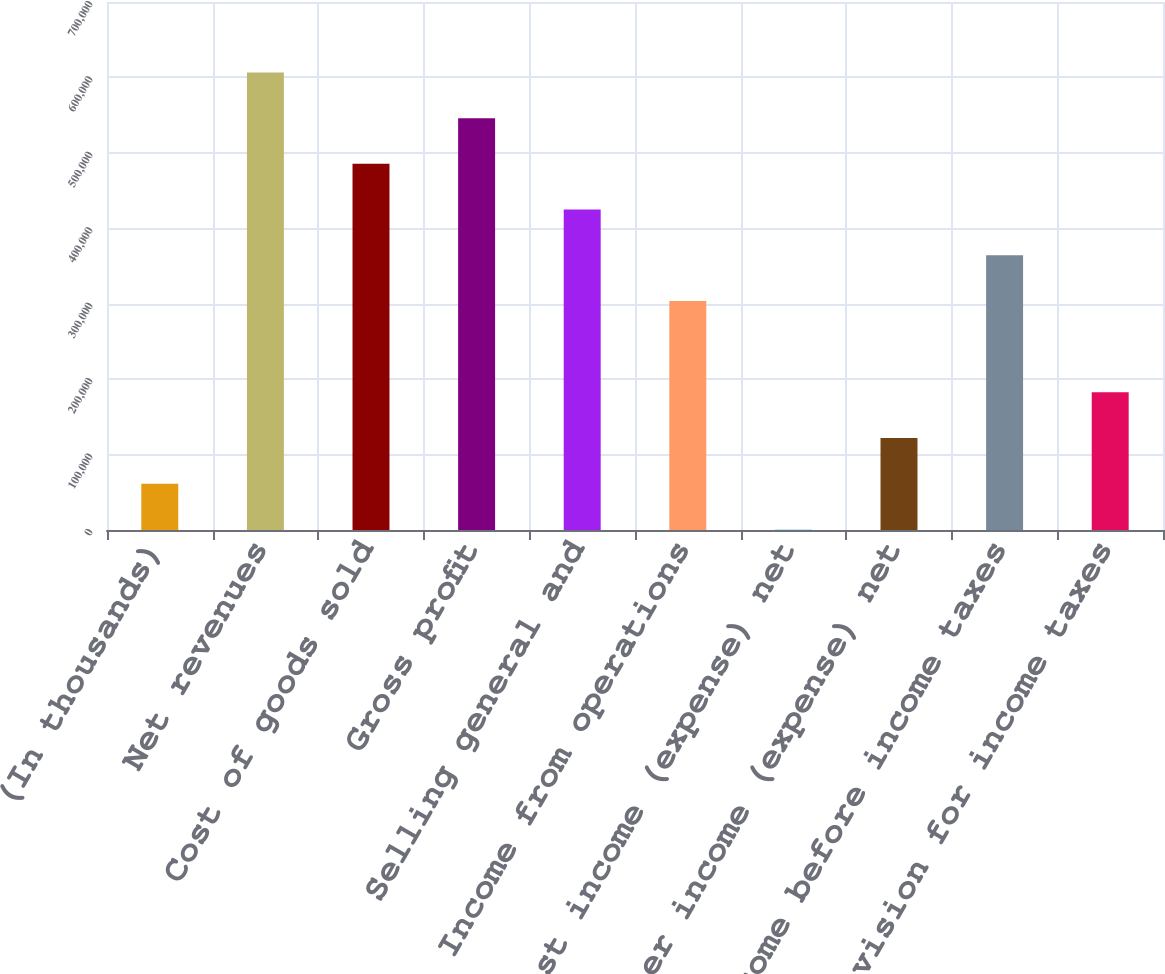Convert chart. <chart><loc_0><loc_0><loc_500><loc_500><bar_chart><fcel>(In thousands)<fcel>Net revenues<fcel>Cost of goods sold<fcel>Gross profit<fcel>Selling general and<fcel>Income from operations<fcel>Interest income (expense) net<fcel>Other income (expense) net<fcel>Income before income taxes<fcel>Provision for income taxes<nl><fcel>61330.2<fcel>606561<fcel>485399<fcel>545980<fcel>424817<fcel>303655<fcel>749<fcel>121911<fcel>364236<fcel>182493<nl></chart> 